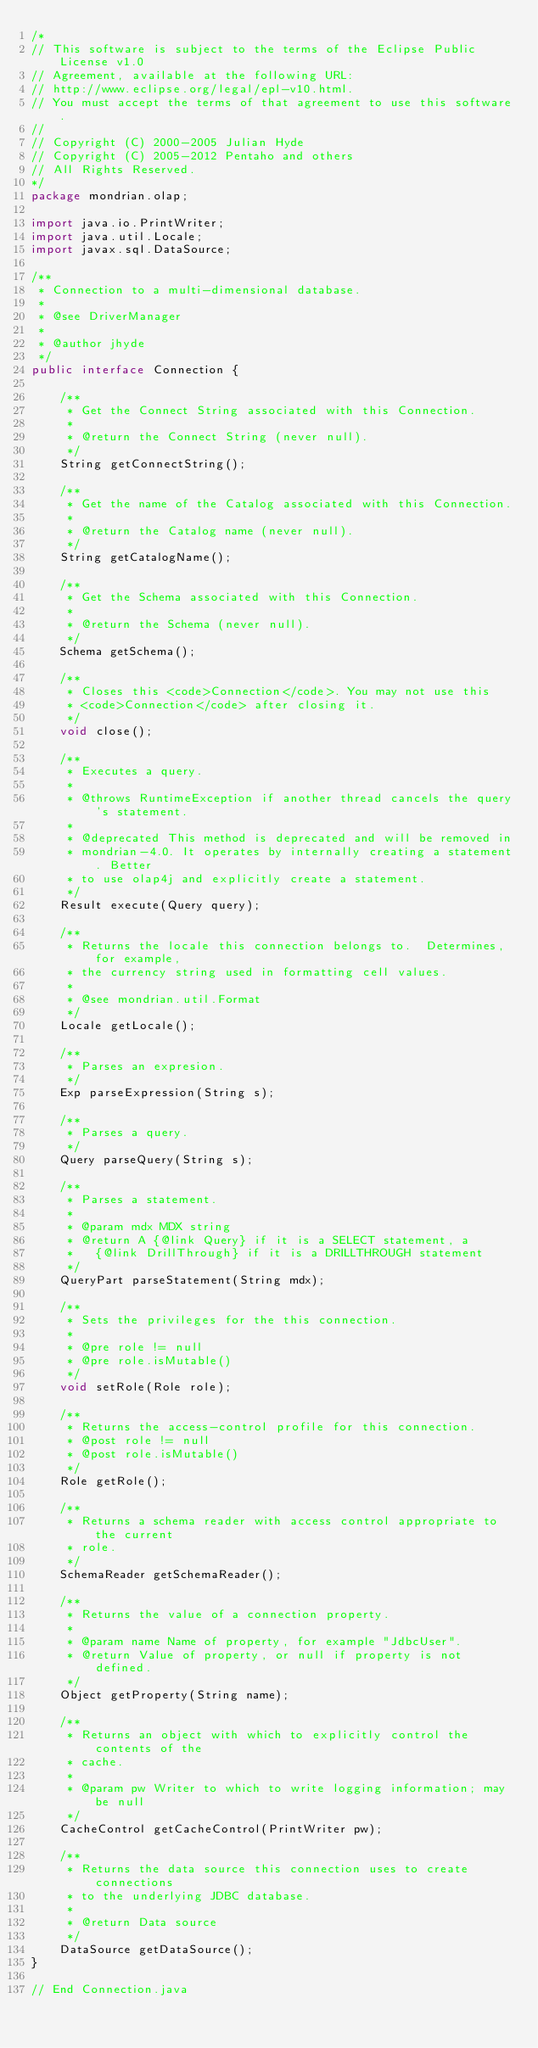<code> <loc_0><loc_0><loc_500><loc_500><_Java_>/*
// This software is subject to the terms of the Eclipse Public License v1.0
// Agreement, available at the following URL:
// http://www.eclipse.org/legal/epl-v10.html.
// You must accept the terms of that agreement to use this software.
//
// Copyright (C) 2000-2005 Julian Hyde
// Copyright (C) 2005-2012 Pentaho and others
// All Rights Reserved.
*/
package mondrian.olap;

import java.io.PrintWriter;
import java.util.Locale;
import javax.sql.DataSource;

/**
 * Connection to a multi-dimensional database.
 *
 * @see DriverManager
 *
 * @author jhyde
 */
public interface Connection {

    /**
     * Get the Connect String associated with this Connection.
     *
     * @return the Connect String (never null).
     */
    String getConnectString();

    /**
     * Get the name of the Catalog associated with this Connection.
     *
     * @return the Catalog name (never null).
     */
    String getCatalogName();

    /**
     * Get the Schema associated with this Connection.
     *
     * @return the Schema (never null).
     */
    Schema getSchema();

    /**
     * Closes this <code>Connection</code>. You may not use this
     * <code>Connection</code> after closing it.
     */
    void close();

    /**
     * Executes a query.
     *
     * @throws RuntimeException if another thread cancels the query's statement.
     *
     * @deprecated This method is deprecated and will be removed in
     * mondrian-4.0. It operates by internally creating a statement. Better
     * to use olap4j and explicitly create a statement.
     */
    Result execute(Query query);

    /**
     * Returns the locale this connection belongs to.  Determines, for example,
     * the currency string used in formatting cell values.
     *
     * @see mondrian.util.Format
     */
    Locale getLocale();

    /**
     * Parses an expresion.
     */
    Exp parseExpression(String s);

    /**
     * Parses a query.
     */
    Query parseQuery(String s);

    /**
     * Parses a statement.
     *
     * @param mdx MDX string
     * @return A {@link Query} if it is a SELECT statement, a
     *   {@link DrillThrough} if it is a DRILLTHROUGH statement
     */
    QueryPart parseStatement(String mdx);

    /**
     * Sets the privileges for the this connection.
     *
     * @pre role != null
     * @pre role.isMutable()
     */
    void setRole(Role role);

    /**
     * Returns the access-control profile for this connection.
     * @post role != null
     * @post role.isMutable()
     */
    Role getRole();

    /**
     * Returns a schema reader with access control appropriate to the current
     * role.
     */
    SchemaReader getSchemaReader();

    /**
     * Returns the value of a connection property.
     *
     * @param name Name of property, for example "JdbcUser".
     * @return Value of property, or null if property is not defined.
     */
    Object getProperty(String name);

    /**
     * Returns an object with which to explicitly control the contents of the
     * cache.
     *
     * @param pw Writer to which to write logging information; may be null
     */
    CacheControl getCacheControl(PrintWriter pw);

    /**
     * Returns the data source this connection uses to create connections
     * to the underlying JDBC database.
     *
     * @return Data source
     */
    DataSource getDataSource();
}

// End Connection.java
</code> 